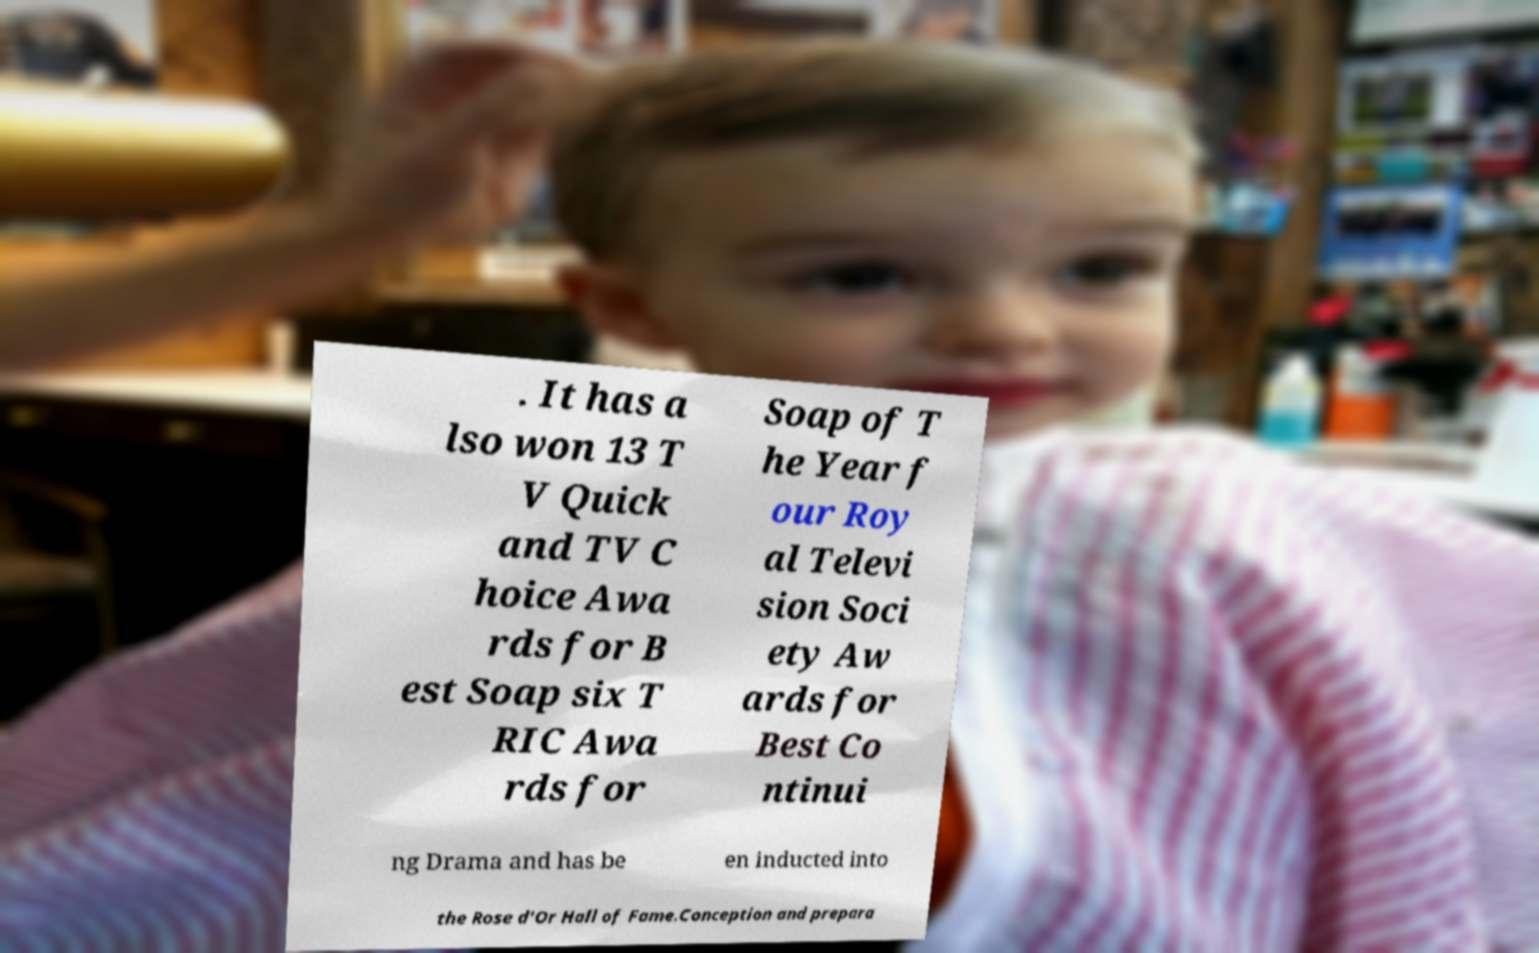Can you read and provide the text displayed in the image?This photo seems to have some interesting text. Can you extract and type it out for me? . It has a lso won 13 T V Quick and TV C hoice Awa rds for B est Soap six T RIC Awa rds for Soap of T he Year f our Roy al Televi sion Soci ety Aw ards for Best Co ntinui ng Drama and has be en inducted into the Rose d'Or Hall of Fame.Conception and prepara 